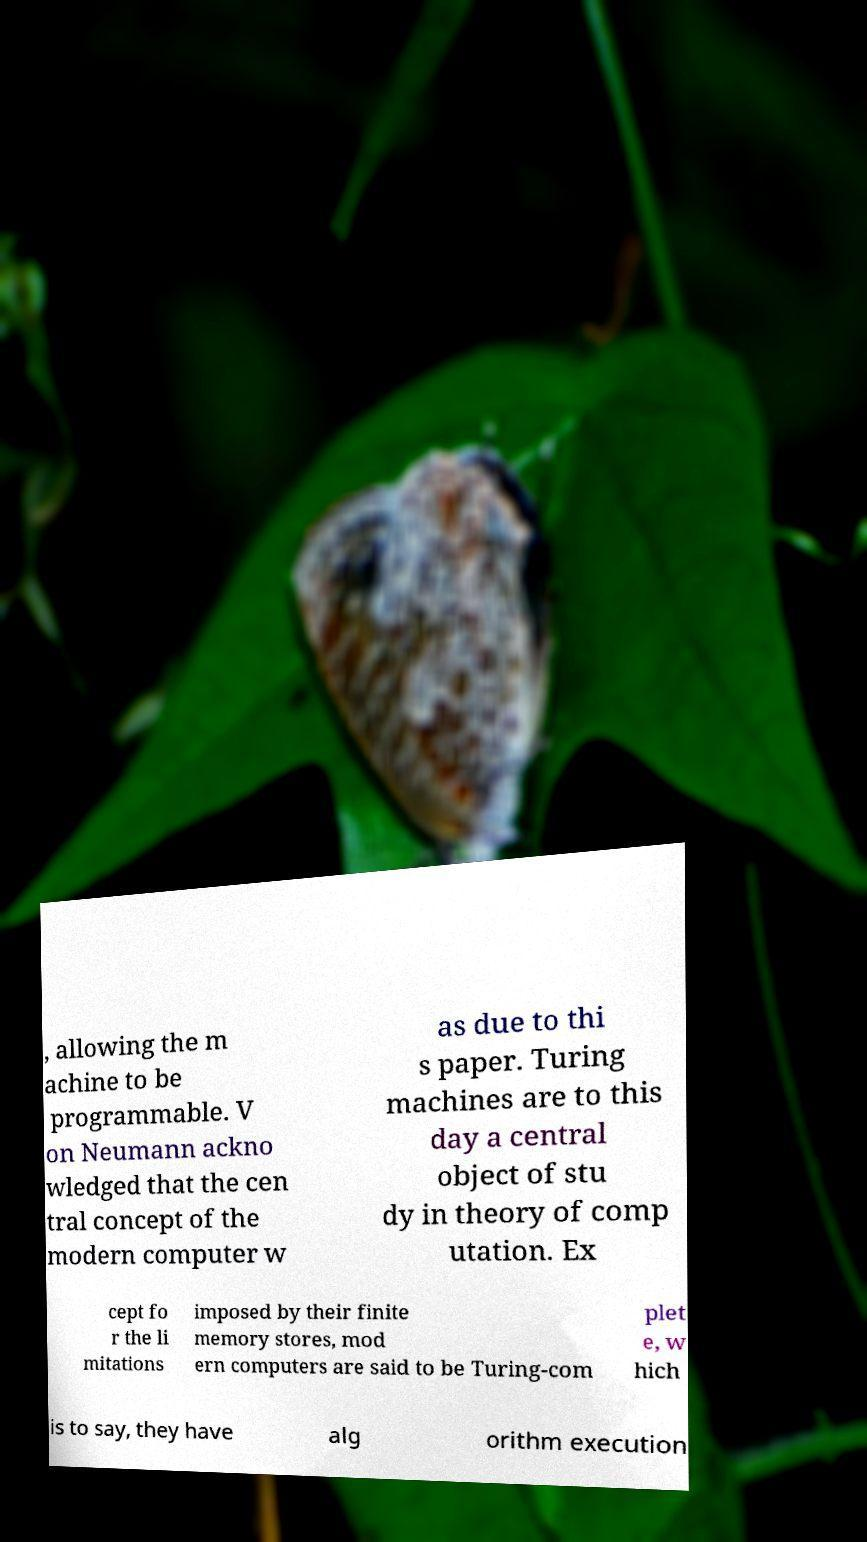For documentation purposes, I need the text within this image transcribed. Could you provide that? , allowing the m achine to be programmable. V on Neumann ackno wledged that the cen tral concept of the modern computer w as due to thi s paper. Turing machines are to this day a central object of stu dy in theory of comp utation. Ex cept fo r the li mitations imposed by their finite memory stores, mod ern computers are said to be Turing-com plet e, w hich is to say, they have alg orithm execution 